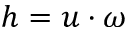Convert formula to latex. <formula><loc_0><loc_0><loc_500><loc_500>h = u \cdot \omega</formula> 